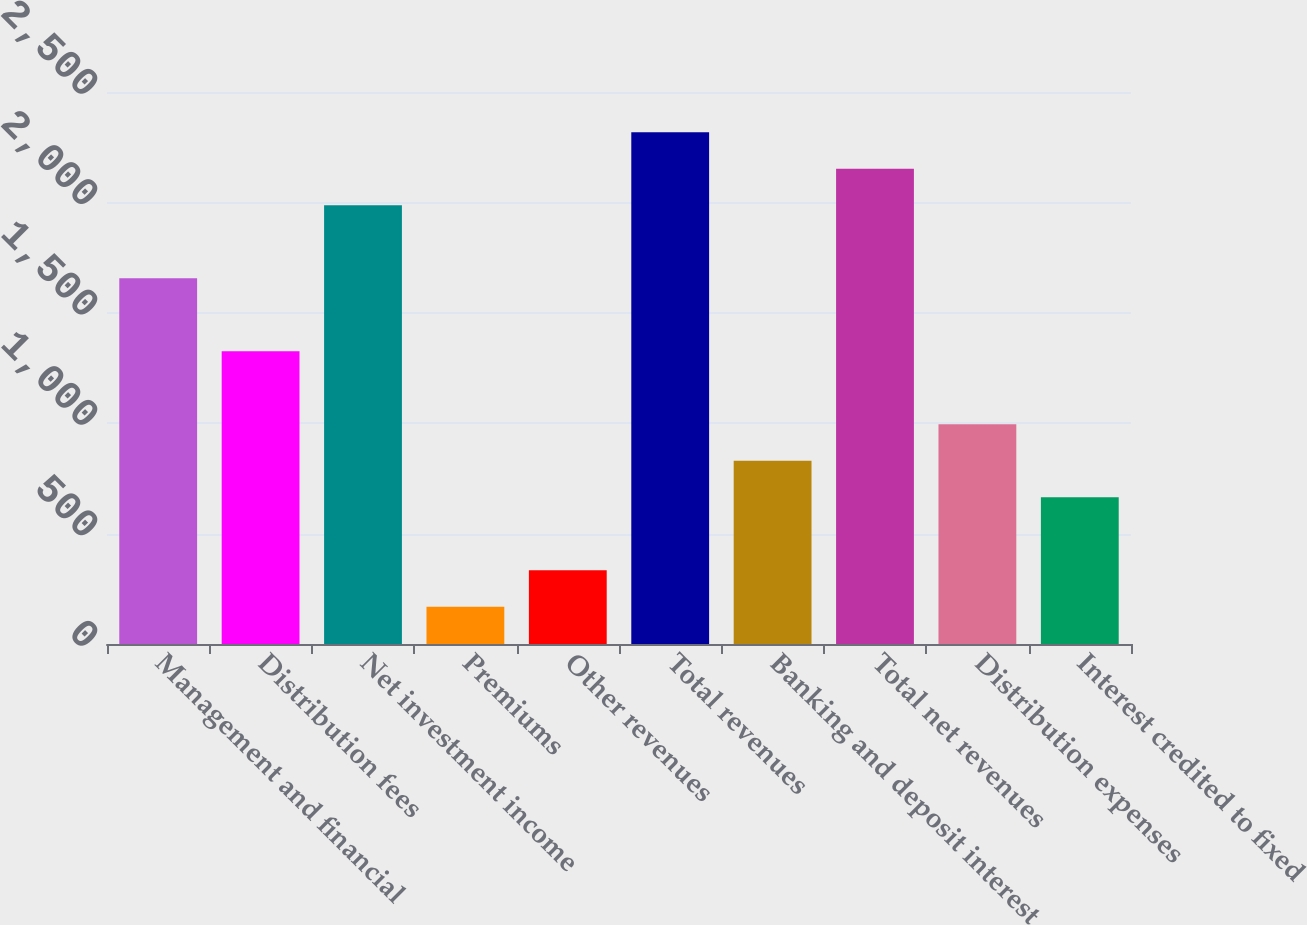Convert chart. <chart><loc_0><loc_0><loc_500><loc_500><bar_chart><fcel>Management and financial<fcel>Distribution fees<fcel>Net investment income<fcel>Premiums<fcel>Other revenues<fcel>Total revenues<fcel>Banking and deposit interest<fcel>Total net revenues<fcel>Distribution expenses<fcel>Interest credited to fixed<nl><fcel>1656<fcel>1325.4<fcel>1986.6<fcel>168.3<fcel>333.6<fcel>2317.2<fcel>829.5<fcel>2151.9<fcel>994.8<fcel>664.2<nl></chart> 